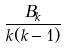Convert formula to latex. <formula><loc_0><loc_0><loc_500><loc_500>\frac { B _ { k } } { k ( k - 1 ) }</formula> 